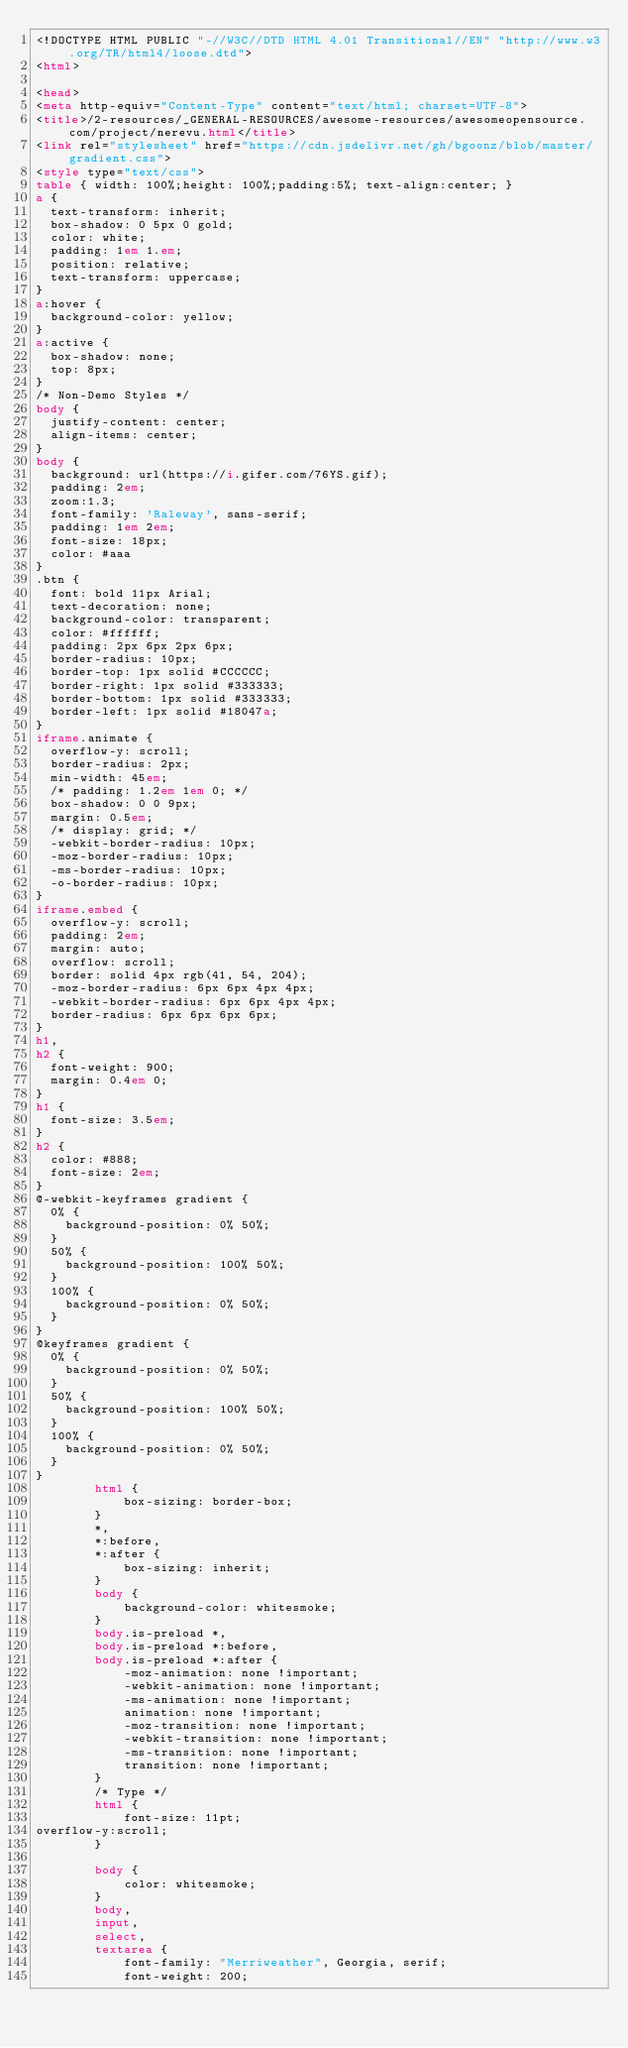Convert code to text. <code><loc_0><loc_0><loc_500><loc_500><_HTML_><!DOCTYPE HTML PUBLIC "-//W3C//DTD HTML 4.01 Transitional//EN" "http://www.w3.org/TR/html4/loose.dtd">
<html>

<head>
<meta http-equiv="Content-Type" content="text/html; charset=UTF-8">
<title>/2-resources/_GENERAL-RESOURCES/awesome-resources/awesomeopensource.com/project/nerevu.html</title>
<link rel="stylesheet" href="https://cdn.jsdelivr.net/gh/bgoonz/blob/master/gradient.css">
<style type="text/css">
table { width: 100%;height: 100%;padding:5%; text-align:center; }
a {
  text-transform: inherit;
  box-shadow: 0 5px 0 gold;
  color: white;
  padding: 1em 1.em;
  position: relative;
  text-transform: uppercase;
}
a:hover {
  background-color: yellow;
}
a:active {
  box-shadow: none;
  top: 8px;
}
/* Non-Demo Styles */
body {
  justify-content: center;
  align-items: center;
}
body {
  background: url(https://i.gifer.com/76YS.gif);
  padding: 2em;
  zoom:1.3;
  font-family: 'Raleway', sans-serif;
  padding: 1em 2em;
  font-size: 18px;
  color: #aaa
}
.btn {
  font: bold 11px Arial;
  text-decoration: none;
  background-color: transparent;
  color: #ffffff;
  padding: 2px 6px 2px 6px;
  border-radius: 10px;
  border-top: 1px solid #CCCCCC;
  border-right: 1px solid #333333;
  border-bottom: 1px solid #333333;
  border-left: 1px solid #18047a;
}
iframe.animate {
  overflow-y: scroll;
  border-radius: 2px;
  min-width: 45em;
  /* padding: 1.2em 1em 0; */
  box-shadow: 0 0 9px;
  margin: 0.5em;
  /* display: grid; */
  -webkit-border-radius: 10px;
  -moz-border-radius: 10px;
  -ms-border-radius: 10px;
  -o-border-radius: 10px;
}
iframe.embed {
  overflow-y: scroll;
  padding: 2em;
  margin: auto;
  overflow: scroll;
  border: solid 4px rgb(41, 54, 204);
  -moz-border-radius: 6px 6px 4px 4px;
  -webkit-border-radius: 6px 6px 4px 4px;
  border-radius: 6px 6px 6px 6px;
}
h1,
h2 {
  font-weight: 900;
  margin: 0.4em 0;
}
h1 {
  font-size: 3.5em;
}
h2 {
  color: #888;
  font-size: 2em;
}
@-webkit-keyframes gradient {
  0% {
    background-position: 0% 50%;
  }
  50% {
    background-position: 100% 50%;
  }
  100% {
    background-position: 0% 50%;
  }
}
@keyframes gradient {
  0% {
    background-position: 0% 50%;
  }
  50% {
    background-position: 100% 50%;
  }
  100% {
    background-position: 0% 50%;
  }
}
        html {
            box-sizing: border-box;
        }
        *,
        *:before,
        *:after {
            box-sizing: inherit;
        }
        body {
            background-color: whitesmoke;
        }
        body.is-preload *,
        body.is-preload *:before,
        body.is-preload *:after {
            -moz-animation: none !important;
            -webkit-animation: none !important;
            -ms-animation: none !important;
            animation: none !important;
            -moz-transition: none !important;
            -webkit-transition: none !important;
            -ms-transition: none !important;
            transition: none !important;
        }
        /* Type */
        html {
            font-size: 11pt;
overflow-y:scroll;
        }
       
        body {
            color: whitesmoke;
        }
        body,
        input,
        select,
        textarea {
            font-family: "Merriweather", Georgia, serif;
            font-weight: 200;</code> 